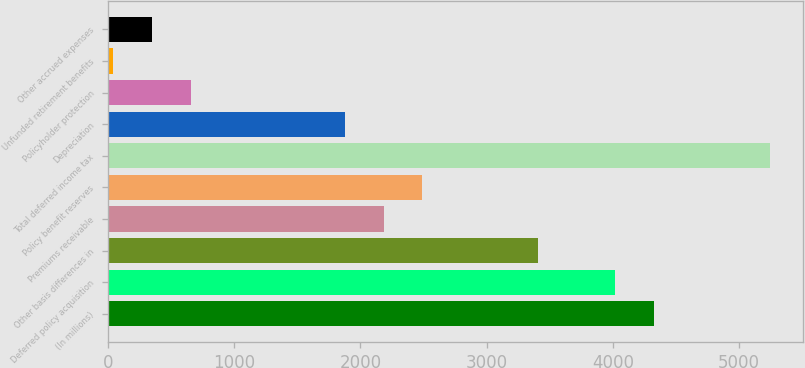Convert chart. <chart><loc_0><loc_0><loc_500><loc_500><bar_chart><fcel>(In millions)<fcel>Deferred policy acquisition<fcel>Other basis differences in<fcel>Premiums receivable<fcel>Policy benefit reserves<fcel>Total deferred income tax<fcel>Depreciation<fcel>Policyholder protection<fcel>Unfunded retirement benefits<fcel>Other accrued expenses<nl><fcel>4327<fcel>4021<fcel>3409<fcel>2185<fcel>2491<fcel>5245<fcel>1879<fcel>655<fcel>43<fcel>349<nl></chart> 